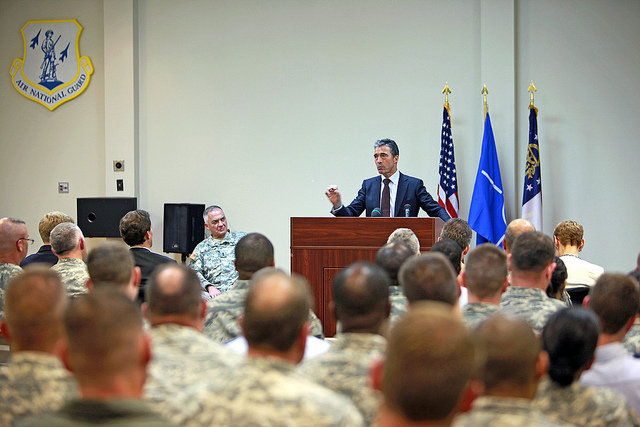Identify and read out the text in this image. GUARD NATIONAL AIR 